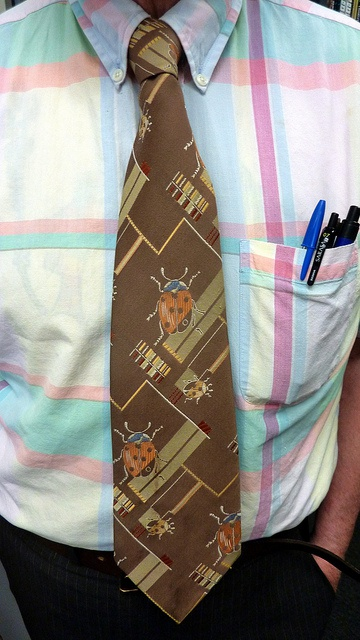Describe the objects in this image and their specific colors. I can see people in lightgray, black, darkgray, and maroon tones and tie in gray, maroon, tan, and olive tones in this image. 